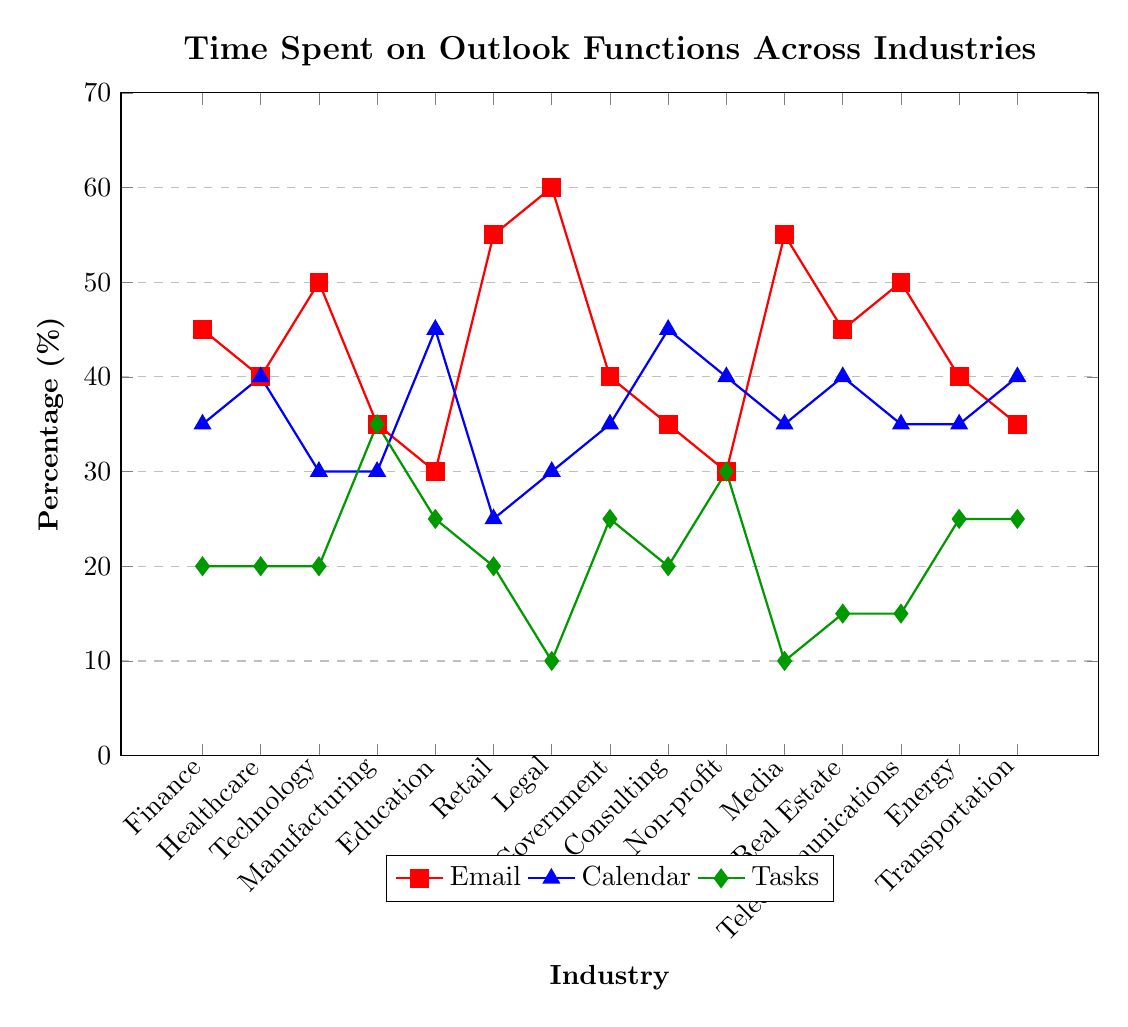Which industry spends the most time on email? Look for the industry with the highest percentage value in the "Email" line on the graph. The Legal industry has the highest percentage at 60%.
Answer: Legal Which industry allocates the least time to tasks? Find the industry with the lowest percentage value in the "Tasks" line. The Legal and Media industries both allocate the least time to tasks, with 10%.
Answer: Legal and Media What's the average percentage of time spent on calendar activities across all industries? Sum the percentages of time spent on calendar activities across all industries and divide by the number of industries: (35+40+30+30+45+25+30+35+45+40+35+40+35+35+40)/15 = 36.33.
Answer: 36.33 Does the Technology industry spend more time on email or calendar? Compare the percentages for email (50%) and calendar (30%) in the Technology industry. The percentage for email is higher.
Answer: Email Which industry has the most balanced use of email, calendar, and tasks? Look for the industry where the values for email, calendar, and tasks are closest to each other. Manufacturing has percentages of 35%, 30%, and 35%, respectively, which are quite balanced.
Answer: Manufacturing Is the time spent on tasks by the non-profit industry higher than the government industry? Compare the percentage of time spent on tasks in the Non-profit industry (30%) with the Government industry (25%). The Non-profit industry spends more time on tasks.
Answer: Yes How much more time does the media industry spend on email compared to the education industry? Subtract the percentage of time spent on email in the Education industry (30%) from that in the Media industry (55%): 55% - 30% = 25%.
Answer: 25% Which industry spends an equal amount of time on email and calendar activities? Look for industries where the percentages for email and calendar are the same. Healthcare spends 40% on both email and calendar activities.
Answer: Healthcare What's the combined percentage of time spent on tasks and calendar activities in the energy industry? Add the percentage of time spent on tasks (25%) and calendar (35%) in the Energy industry: 25% + 35% = 60%.
Answer: 60% Compare the time spent on email in the finance industry with the time spent on email in the retail industry. Which one is higher? Compare the percentages for the finance industry (45%) and retail industry (55%). The retail industry spends more time on email.
Answer: Retail 